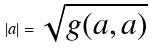Convert formula to latex. <formula><loc_0><loc_0><loc_500><loc_500>| a | = \sqrt { g ( a , a ) }</formula> 